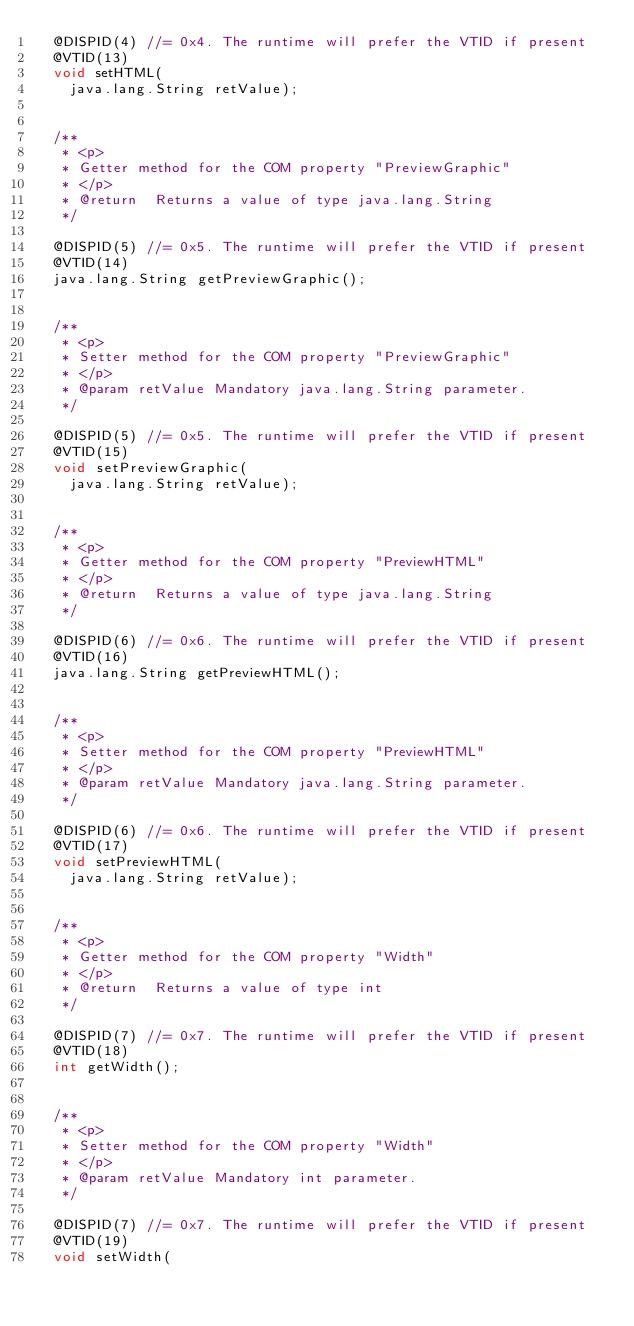Convert code to text. <code><loc_0><loc_0><loc_500><loc_500><_Java_>  @DISPID(4) //= 0x4. The runtime will prefer the VTID if present
  @VTID(13)
  void setHTML(
    java.lang.String retValue);


  /**
   * <p>
   * Getter method for the COM property "PreviewGraphic"
   * </p>
   * @return  Returns a value of type java.lang.String
   */

  @DISPID(5) //= 0x5. The runtime will prefer the VTID if present
  @VTID(14)
  java.lang.String getPreviewGraphic();


  /**
   * <p>
   * Setter method for the COM property "PreviewGraphic"
   * </p>
   * @param retValue Mandatory java.lang.String parameter.
   */

  @DISPID(5) //= 0x5. The runtime will prefer the VTID if present
  @VTID(15)
  void setPreviewGraphic(
    java.lang.String retValue);


  /**
   * <p>
   * Getter method for the COM property "PreviewHTML"
   * </p>
   * @return  Returns a value of type java.lang.String
   */

  @DISPID(6) //= 0x6. The runtime will prefer the VTID if present
  @VTID(16)
  java.lang.String getPreviewHTML();


  /**
   * <p>
   * Setter method for the COM property "PreviewHTML"
   * </p>
   * @param retValue Mandatory java.lang.String parameter.
   */

  @DISPID(6) //= 0x6. The runtime will prefer the VTID if present
  @VTID(17)
  void setPreviewHTML(
    java.lang.String retValue);


  /**
   * <p>
   * Getter method for the COM property "Width"
   * </p>
   * @return  Returns a value of type int
   */

  @DISPID(7) //= 0x7. The runtime will prefer the VTID if present
  @VTID(18)
  int getWidth();


  /**
   * <p>
   * Setter method for the COM property "Width"
   * </p>
   * @param retValue Mandatory int parameter.
   */

  @DISPID(7) //= 0x7. The runtime will prefer the VTID if present
  @VTID(19)
  void setWidth(</code> 